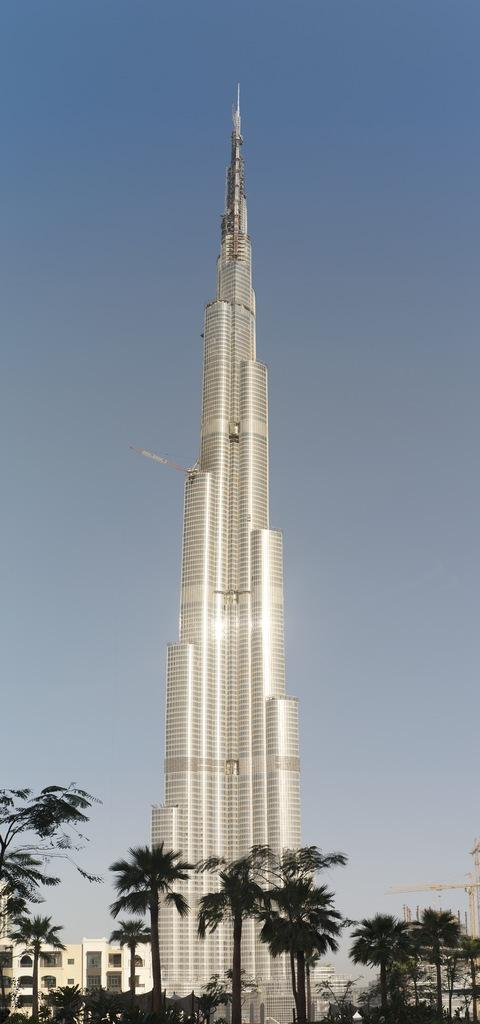What is the main structure in the image? There is a tower in the image. What else can be seen in the image besides the tower? There are buildings and trees in the image. What is visible in the background of the image? The sky is visible in the background of the image. What type of machine can be seen operating in the zoo in the image? There is no machine or zoo present in the image; it features a tower, buildings, trees, and the sky. 